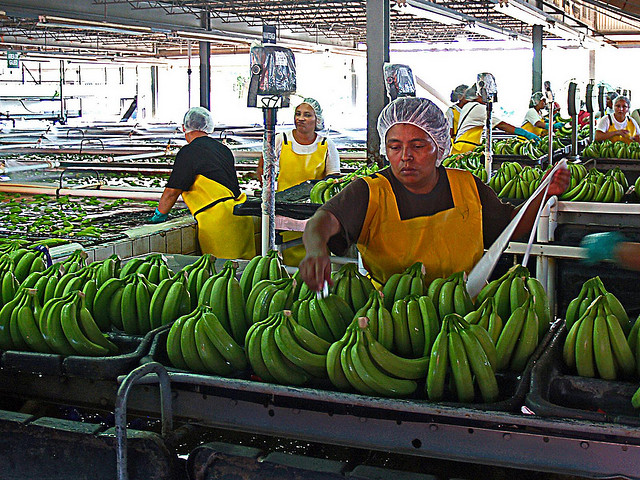What safety or hygiene practices are evident in this image? The workers are wearing hair caps as a hygiene practice to prevent hair from contaminating the food. Additionally, their aprons suggest the use of protective clothing to keep their clothes clean and to prevent any potential contaminants from affecting the product. It's also likely there are procedures in place for regular hand washing and the sanitation of equipment, though these are not directly visible in the image. 